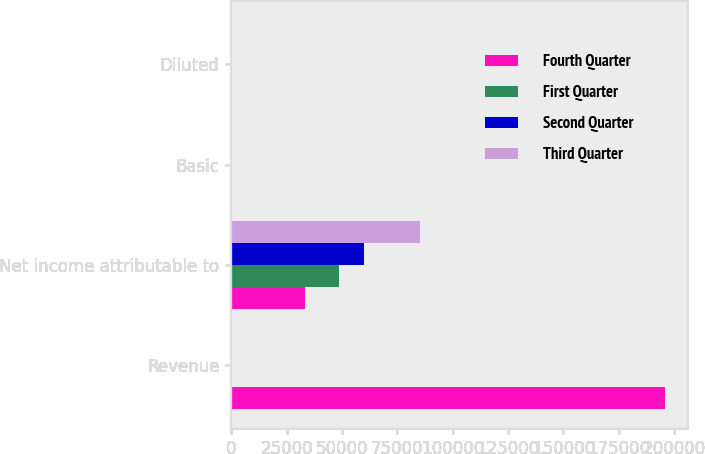<chart> <loc_0><loc_0><loc_500><loc_500><stacked_bar_chart><ecel><fcel>Revenue<fcel>Net income attributable to<fcel>Basic<fcel>Diluted<nl><fcel>Fourth Quarter<fcel>196131<fcel>33242<fcel>0.26<fcel>0.26<nl><fcel>First Quarter<fcel>132<fcel>48472<fcel>0.28<fcel>0.28<nl><fcel>Second Quarter<fcel>132<fcel>59798<fcel>0.35<fcel>0.35<nl><fcel>Third Quarter<fcel>132<fcel>85309<fcel>0.5<fcel>0.5<nl></chart> 